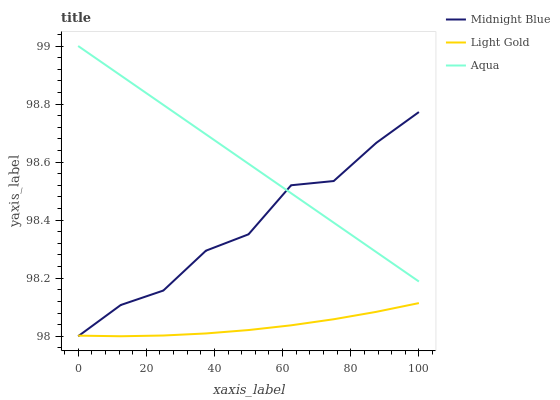Does Light Gold have the minimum area under the curve?
Answer yes or no. Yes. Does Aqua have the maximum area under the curve?
Answer yes or no. Yes. Does Midnight Blue have the minimum area under the curve?
Answer yes or no. No. Does Midnight Blue have the maximum area under the curve?
Answer yes or no. No. Is Aqua the smoothest?
Answer yes or no. Yes. Is Midnight Blue the roughest?
Answer yes or no. Yes. Is Light Gold the smoothest?
Answer yes or no. No. Is Light Gold the roughest?
Answer yes or no. No. Does Midnight Blue have the lowest value?
Answer yes or no. Yes. Does Light Gold have the lowest value?
Answer yes or no. No. Does Aqua have the highest value?
Answer yes or no. Yes. Does Midnight Blue have the highest value?
Answer yes or no. No. Is Light Gold less than Aqua?
Answer yes or no. Yes. Is Aqua greater than Light Gold?
Answer yes or no. Yes. Does Midnight Blue intersect Aqua?
Answer yes or no. Yes. Is Midnight Blue less than Aqua?
Answer yes or no. No. Is Midnight Blue greater than Aqua?
Answer yes or no. No. Does Light Gold intersect Aqua?
Answer yes or no. No. 